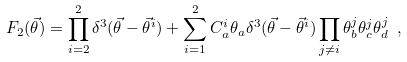<formula> <loc_0><loc_0><loc_500><loc_500>F _ { 2 } ( { \vec { \theta } } ) = \prod _ { i = 2 } ^ { 2 } \delta ^ { 3 } ( { \vec { \theta } } - { \vec { \theta } } ^ { i } ) + \sum _ { i = 1 } ^ { 2 } C _ { a } ^ { i } \theta _ { a } \delta ^ { 3 } ( { \vec { \theta } } - { \vec { \theta } } ^ { i } ) \prod _ { j \neq i } \theta _ { b } ^ { j } \theta _ { c } ^ { j } \theta _ { d } ^ { j } \ ,</formula> 